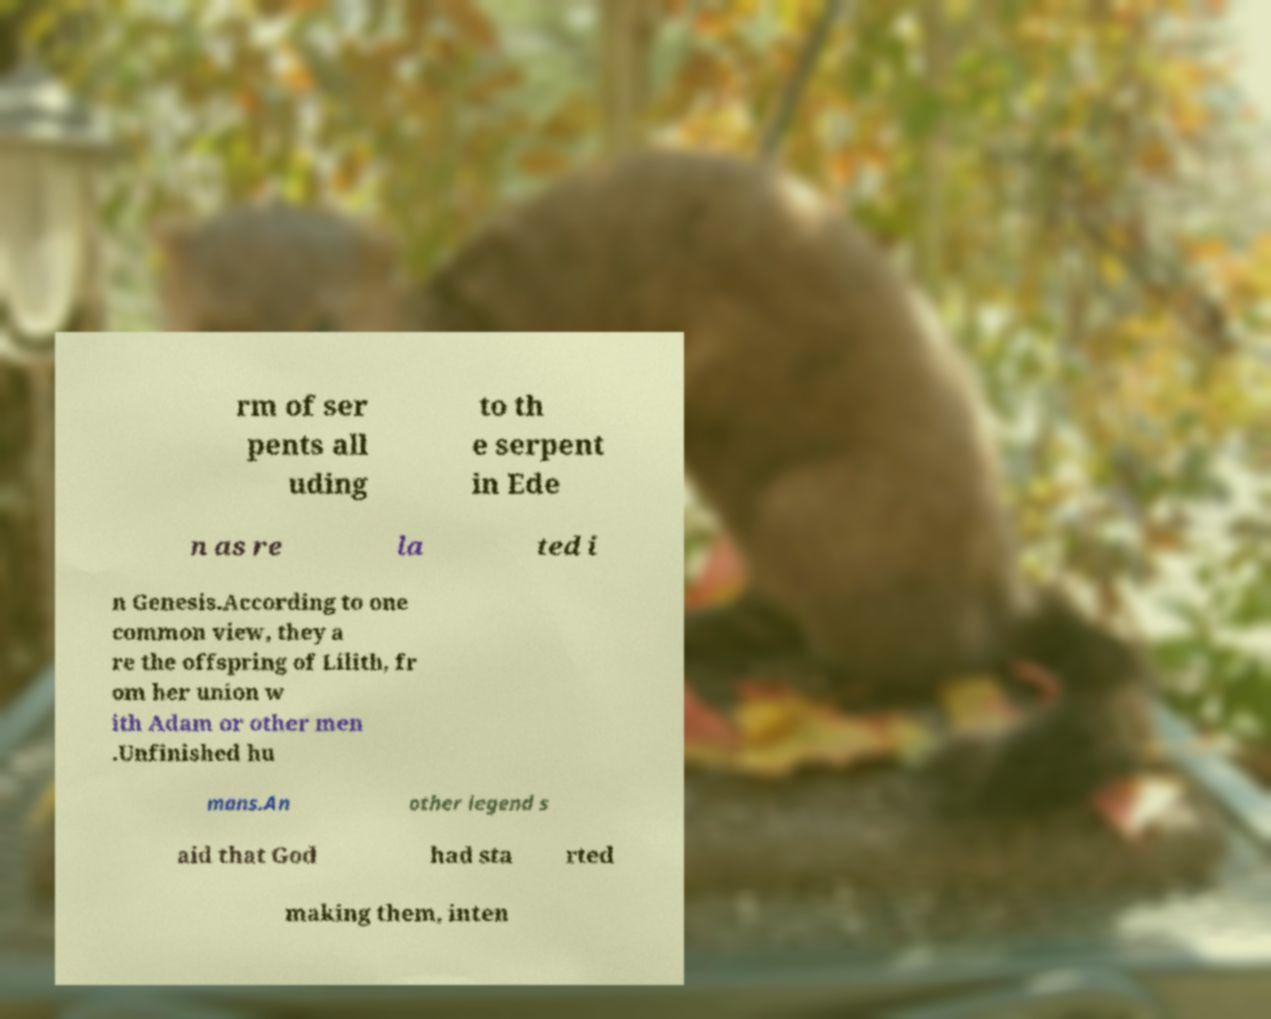Please identify and transcribe the text found in this image. rm of ser pents all uding to th e serpent in Ede n as re la ted i n Genesis.According to one common view, they a re the offspring of Lilith, fr om her union w ith Adam or other men .Unfinished hu mans.An other legend s aid that God had sta rted making them, inten 